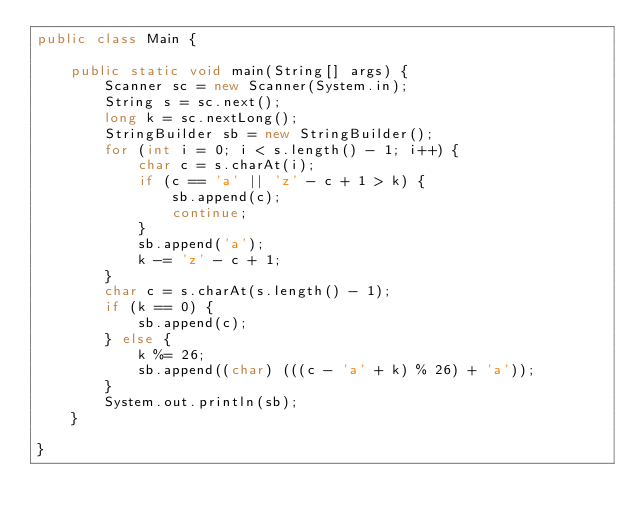<code> <loc_0><loc_0><loc_500><loc_500><_Java_>public class Main {

    public static void main(String[] args) {
        Scanner sc = new Scanner(System.in);
        String s = sc.next();
        long k = sc.nextLong();
        StringBuilder sb = new StringBuilder();
        for (int i = 0; i < s.length() - 1; i++) {
            char c = s.charAt(i);
            if (c == 'a' || 'z' - c + 1 > k) {
                sb.append(c);
                continue;
            }
            sb.append('a');
            k -= 'z' - c + 1;
        }
        char c = s.charAt(s.length() - 1);
        if (k == 0) {
            sb.append(c);
        } else {
            k %= 26;
            sb.append((char) (((c - 'a' + k) % 26) + 'a'));
        }
        System.out.println(sb);
    }

}</code> 